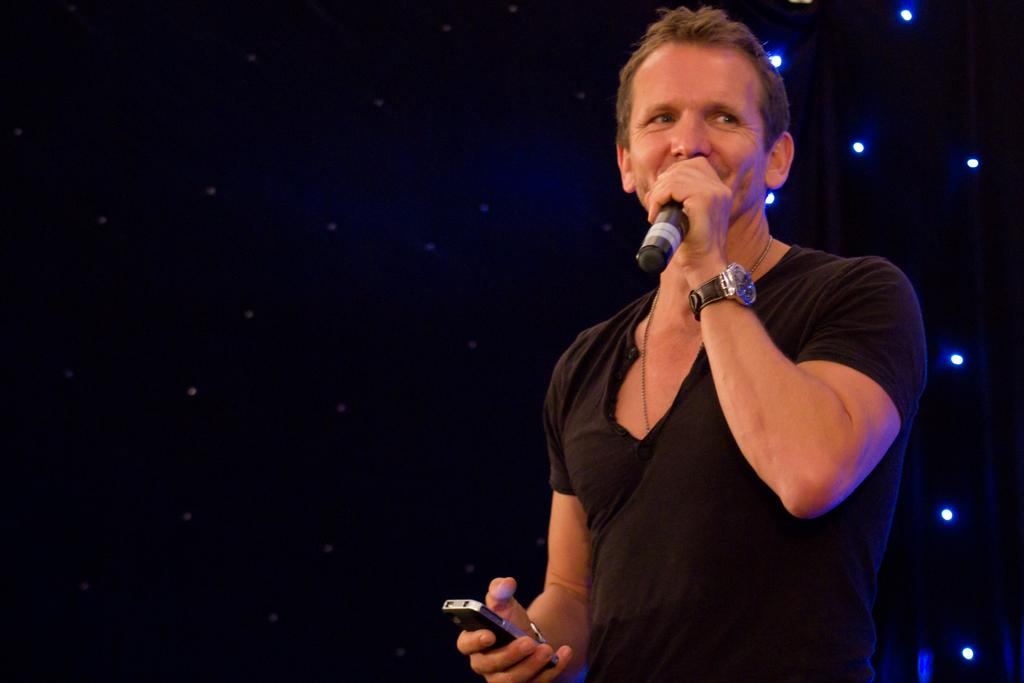Who is the main subject in the image? There is a man in the image. What is the man wearing? The man is wearing a black T-shirt. What is the man doing in the image? The man is talking into a microphone and holding a mobile phone. What can be seen in the background of the image? There are small lights in the background of the image, and the background is dark. What type of birds can be seen in the image? There are no birds present in the image. What color are the man's shoes in the image? The man is not wearing any shoes in the image. 